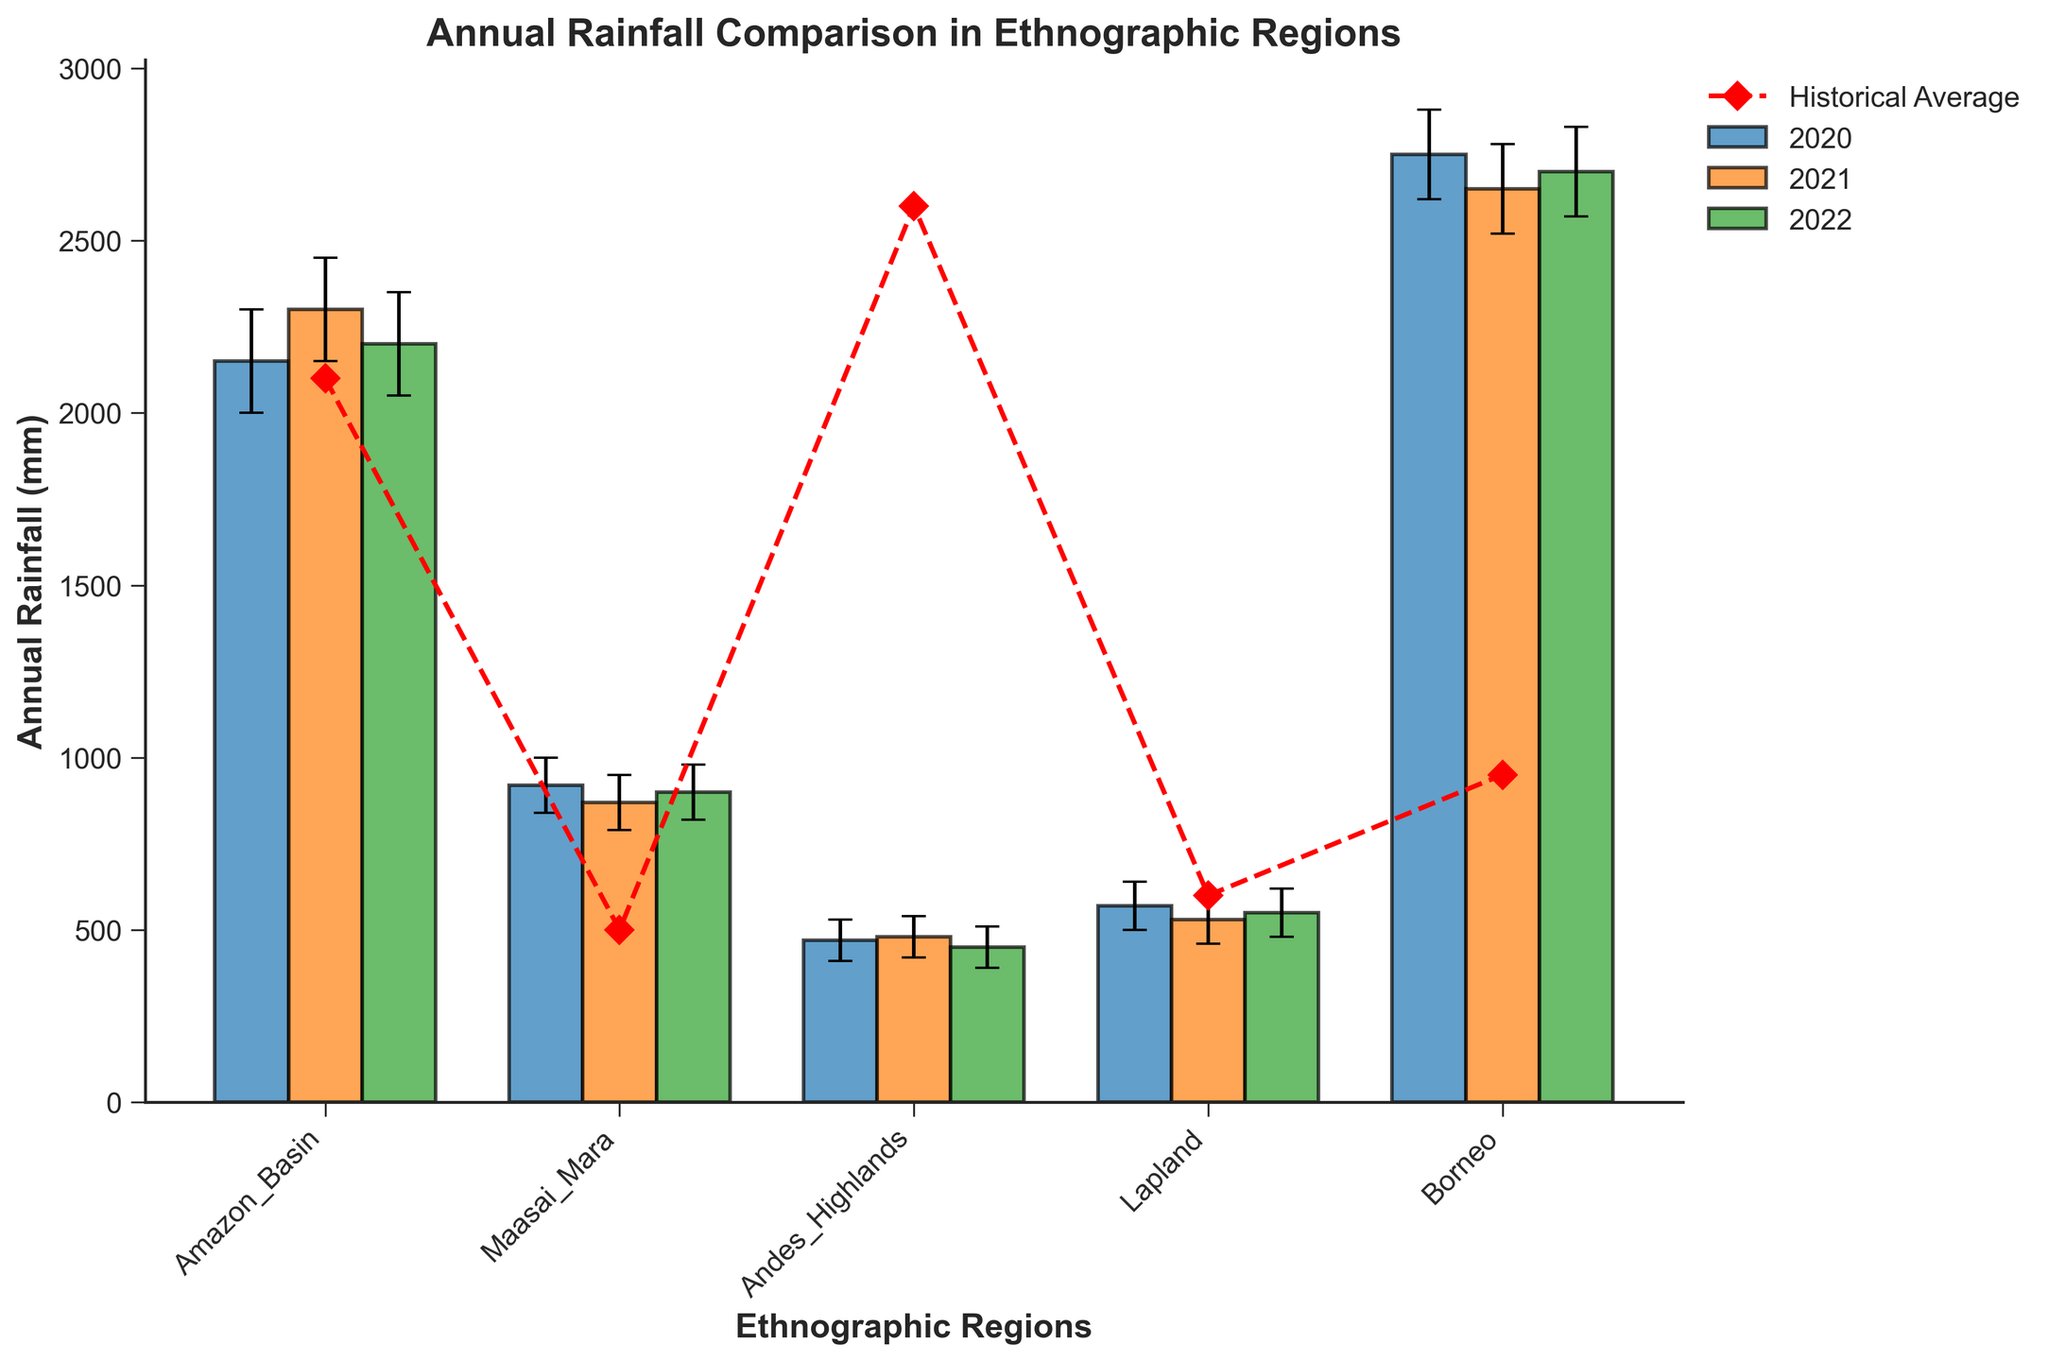What is the title of the plot? The title of a plot is usually mentioned at the top of the figure in larger or bold font.
Answer: Annual Rainfall Comparison in Ethnographic Regions How many ethnographic regions are compared in the figure? Count the number of unique labels on the x-axis.
Answer: 5 In which region and year was the highest annual rainfall recorded? Look for the tallest bar in the plot and identify its corresponding region and year.
Answer: Borneo, 2020 How does the annual rainfall in the Maasai Mara in 2022 compare to its historical average? Compare the height of the bar for Maasai Mara in 2022 with the red diamond that represents the historical average for the same region.
Answer: Lower What is the uncertainty in the annual rainfall measurement for the Andes Highlands in 2021? Look at the error bars extending from the top of the bar for Andes Highlands in 2021.
Answer: 60 mm In which year did the Amazon Basin have its lowest annual rainfall, and how does it compare to the historical average? Identify the shortest bar for the Amazon Basin and compare it to the historical average line for the same region.
Answer: 2020, Higher Which region has the smallest uncertainty in its annual rainfall measurements, and what is the value? Find the region with the shortest error bars in all years. Sum or average the uncertainties if multiple years are present.
Answer: Maasai Mara, 80 mm Did any region have an annual rainfall higher than its historical average in all three years shown? Compare each bar to the corresponding red diamond across all three years for each region.
Answer: No By how much did the rainfall in Lapland change from 2021 to 2022? Was it an increase or a decrease? Subtract the height of the bar for Lapland in 2021 from the height of the bar for 2022. Note which year is higher.
Answer: 20 mm increase 